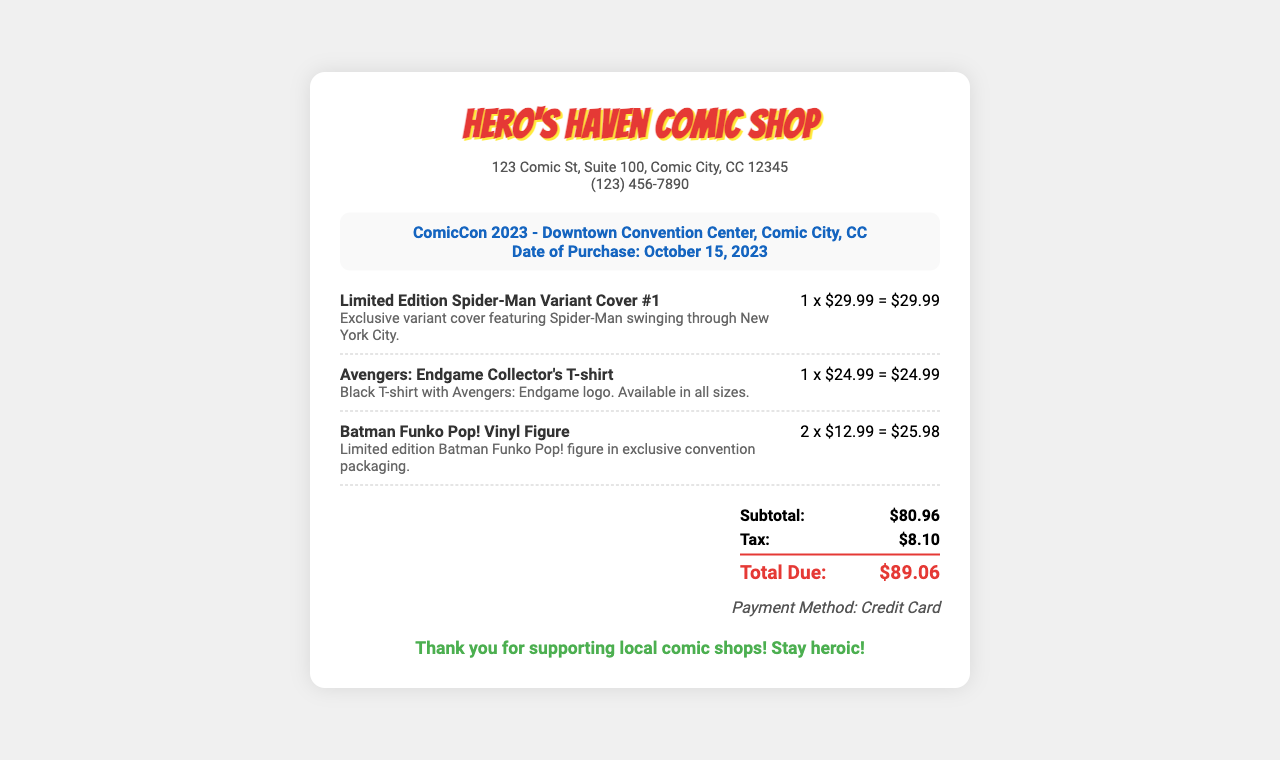What is the name of the comic shop? The receipt states the name of the comic shop as "Hero's Haven Comic Shop."
Answer: Hero's Haven Comic Shop What is the total amount due? The total amount due is indicated as "Total Due" on the receipt, which is $89.06.
Answer: $89.06 When was the purchase made? The receipt mentions the date of purchase as "October 15, 2023."
Answer: October 15, 2023 What item has a price of $29.99? The document lists the "Limited Edition Spider-Man Variant Cover #1" with a price of $29.99.
Answer: Limited Edition Spider-Man Variant Cover #1 How many Batman Funko Pop! figures were purchased? The receipt shows "2 x $12.99" for the Batman Funko Pop! indicating that 2 figures were purchased.
Answer: 2 What is the subtotal before tax? The subtotal is provided in the document as "$80.96."
Answer: $80.96 What color is the Avengers: Endgame T-shirt? The item description specifies the color of the Avengers: Endgame T-shirt as "Black."
Answer: Black What payment method was used for the purchase? The receipt details the payment method as "Credit Card."
Answer: Credit Card What message is displayed at the bottom of the receipt? The last line expresses gratitude with the message "Thank you for supporting local comic shops! Stay heroic!"
Answer: Thank you for supporting local comic shops! Stay heroic! 